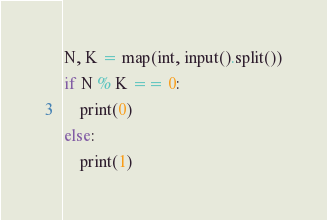<code> <loc_0><loc_0><loc_500><loc_500><_Python_>N, K = map(int, input().split())
if N % K == 0:
    print(0)
else:
    print(1)</code> 